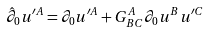Convert formula to latex. <formula><loc_0><loc_0><loc_500><loc_500>\text {\ } \hat { \partial } _ { 0 } u ^ { \prime A } = \partial _ { 0 } u ^ { \prime A } + G _ { B C } ^ { A } \partial _ { 0 } u ^ { B } u ^ { \prime C }</formula> 